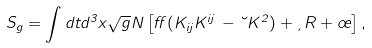<formula> <loc_0><loc_0><loc_500><loc_500>S _ { g } = \int d t d ^ { 3 } x \sqrt { g } N \left [ \alpha ( K _ { i j } K ^ { i j } \, - \lambda K ^ { 2 } ) + \xi R + \sigma \right ] ,</formula> 